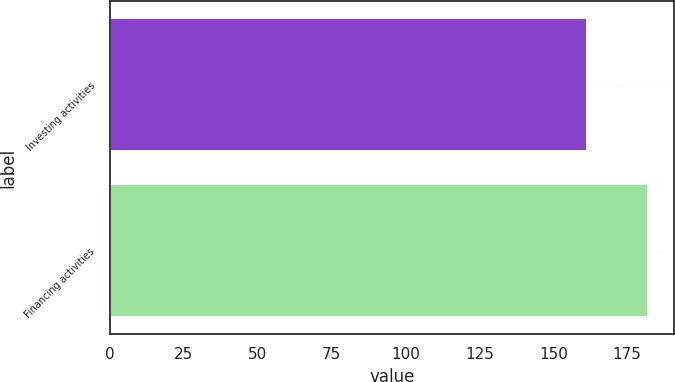Convert chart to OTSL. <chart><loc_0><loc_0><loc_500><loc_500><bar_chart><fcel>Investing activities<fcel>Financing activities<nl><fcel>161.5<fcel>181.9<nl></chart> 